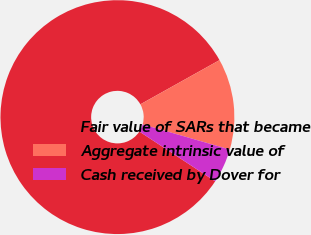Convert chart to OTSL. <chart><loc_0><loc_0><loc_500><loc_500><pie_chart><fcel>Fair value of SARs that became<fcel>Aggregate intrinsic value of<fcel>Cash received by Dover for<nl><fcel>82.65%<fcel>12.57%<fcel>4.78%<nl></chart> 